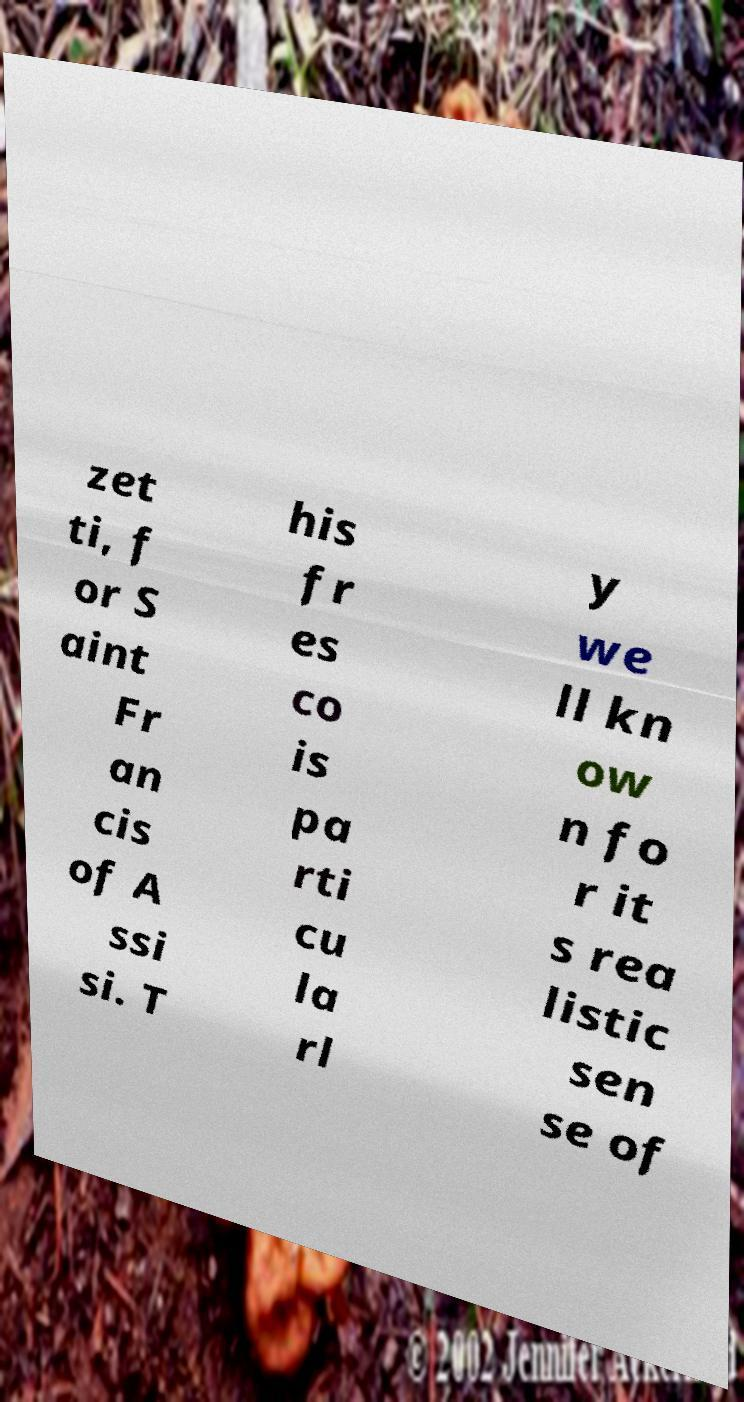Please read and relay the text visible in this image. What does it say? zet ti, f or S aint Fr an cis of A ssi si. T his fr es co is pa rti cu la rl y we ll kn ow n fo r it s rea listic sen se of 